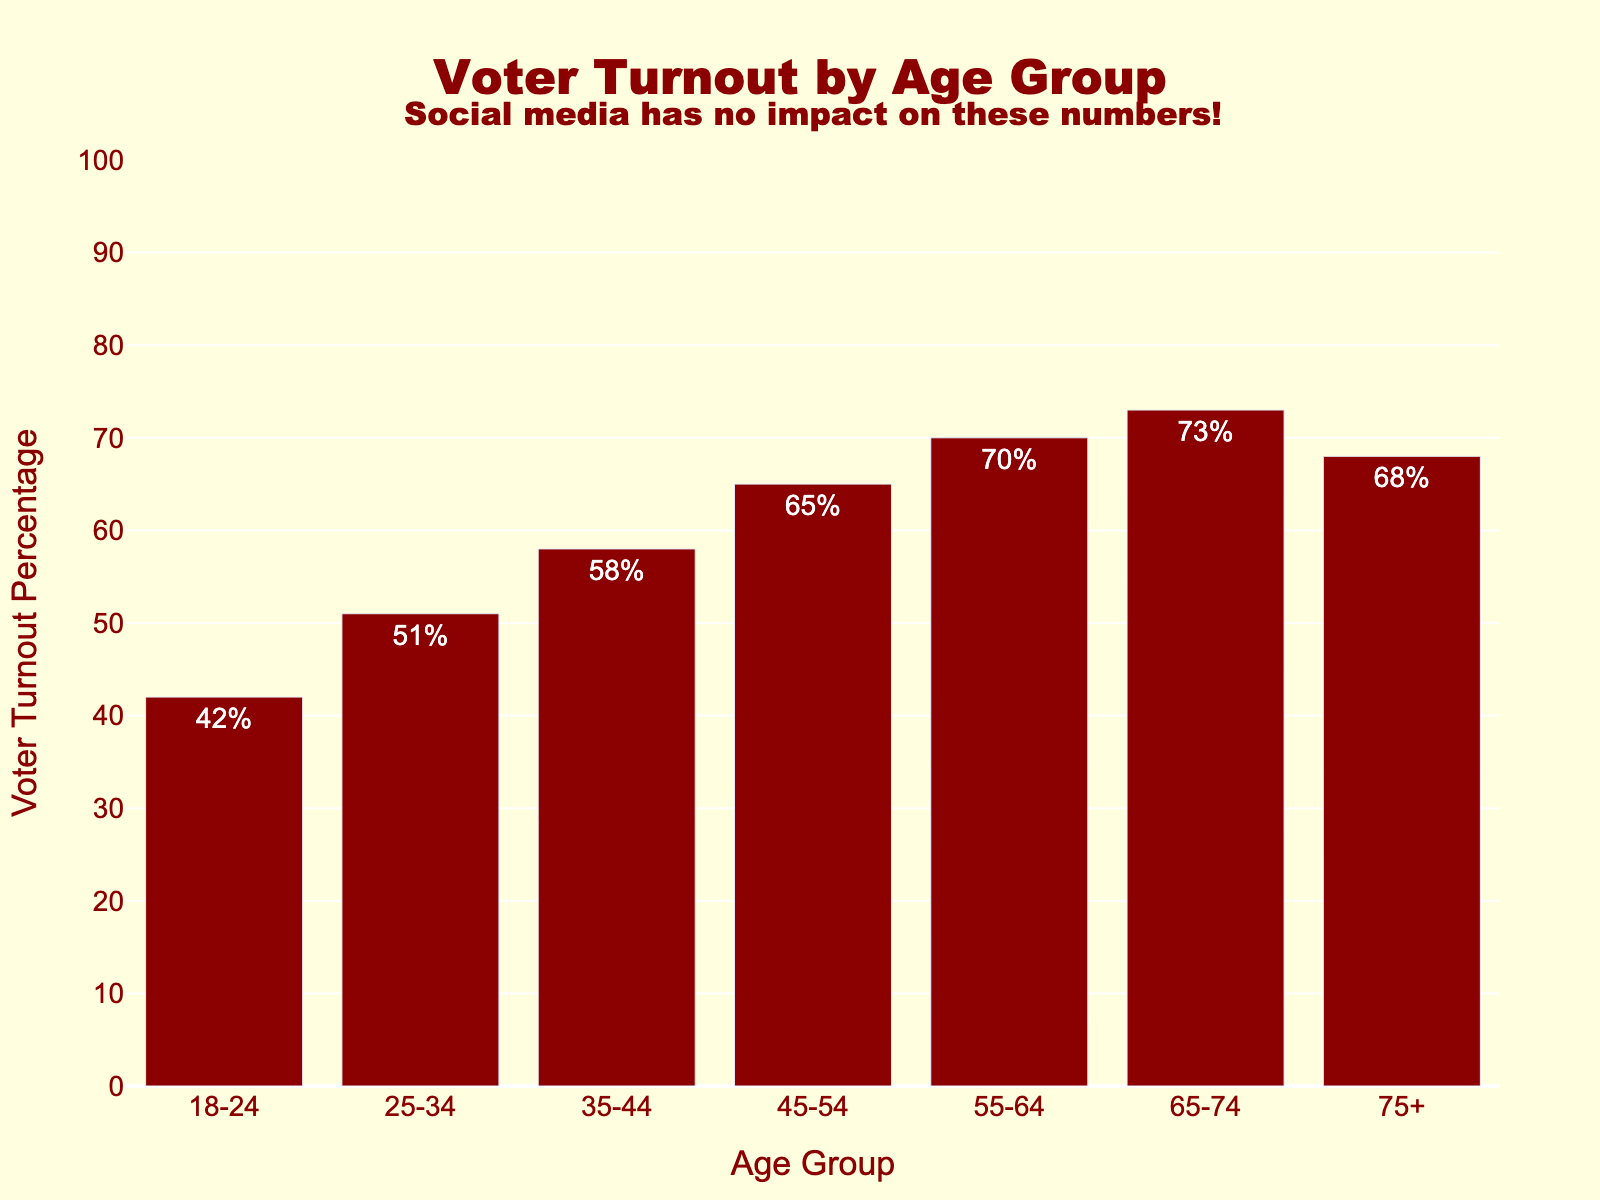What's the difference in voter turnout percentage between the 18-24 and 65-74 age groups? The voter turnout percentage for the 18-24 age group is 42%, and for the 65-74 age group, it is 73%. The difference is 73% - 42%.
Answer: 31% Which age group has the highest voter turnout percentage? By visually inspecting the highest bar, the 65-74 age group has the highest voter turnout percentage.
Answer: 65-74 Is the voter turnout percentage for the 75+ age group higher or lower than that of the 55-64 age group? By comparing the heights of the bars, the 75+ age group has a voter turnout percentage of 68%, while the 55-64 age group has 70%. 68% is lower than 70%.
Answer: Lower What's the average voter turnout percentage across all age groups? Summing up the voter turnout percentages (42 + 51 + 58 + 65 + 70 + 73 + 68) equals 427. There are 7 age groups, so the average is 427 / 7.
Answer: 61% How many age groups have a voter turnout percentage of 60% or more? The age groups with a percentage of 60% or more are 45-54 (65%), 55-64 (70%), 65-74 (73%), and 75+ (68%). That’s 4 age groups in total.
Answer: 4 Which age group has a voter turnout percentage closest to the overall average voter turnout percentage? First, calculate the overall average (427 / 7 = 61%). The percentages are 42, 51, 58, 65, 70, 73, 68. The closest to 61% is 58%. Therefore, the age group is 35-44.
Answer: 35-44 What is the combined voter turnout percentage for the age groups 25-34 and 35-44? The voter turnout percentages are 51% for 25-34 and 58% for 35-44. The combined sum is 51% + 58%.
Answer: 109% Does any age group have a voter turnout percentage exactly equal to 70%? By checking the bars, the 55-64 age group has a voter turnout percentage of 70%.
Answer: Yes, 55-64 Which two consecutive age groups have the smallest difference in voter turnout percentages? Calculate the differences: 
18-24 to 25-34 (51% - 42% = 9%), 
25-34 to 35-44 (58% - 51% = 7%), 
35-44 to 45-54 (65% - 58% = 7%), 
45-54 to 55-64 (70% - 65% = 5%), 
55-64 to 65-74 (73% - 70% = 3%), 
and 65-74 to 75+ (68% - 73% = 5%). The smallest difference is between 55-64 and 65-74 (3%).
Answer: 55-64 and 65-74 